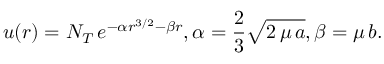<formula> <loc_0><loc_0><loc_500><loc_500>u ( r ) = N _ { T } \, e ^ { - \alpha r ^ { 3 / 2 } - \beta r } , \alpha = \frac { 2 } { 3 } \sqrt { 2 \, \mu \, a } , \beta = \mu \, b .</formula> 